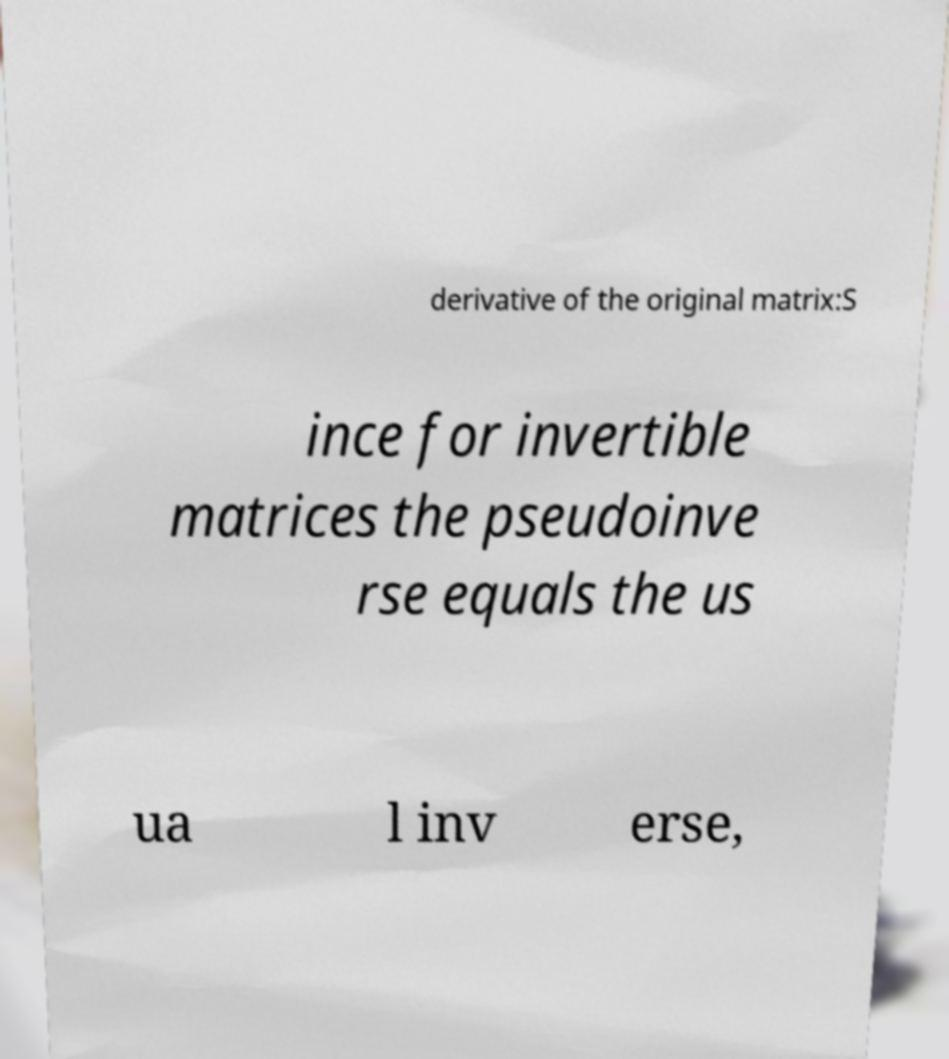There's text embedded in this image that I need extracted. Can you transcribe it verbatim? derivative of the original matrix:S ince for invertible matrices the pseudoinve rse equals the us ua l inv erse, 